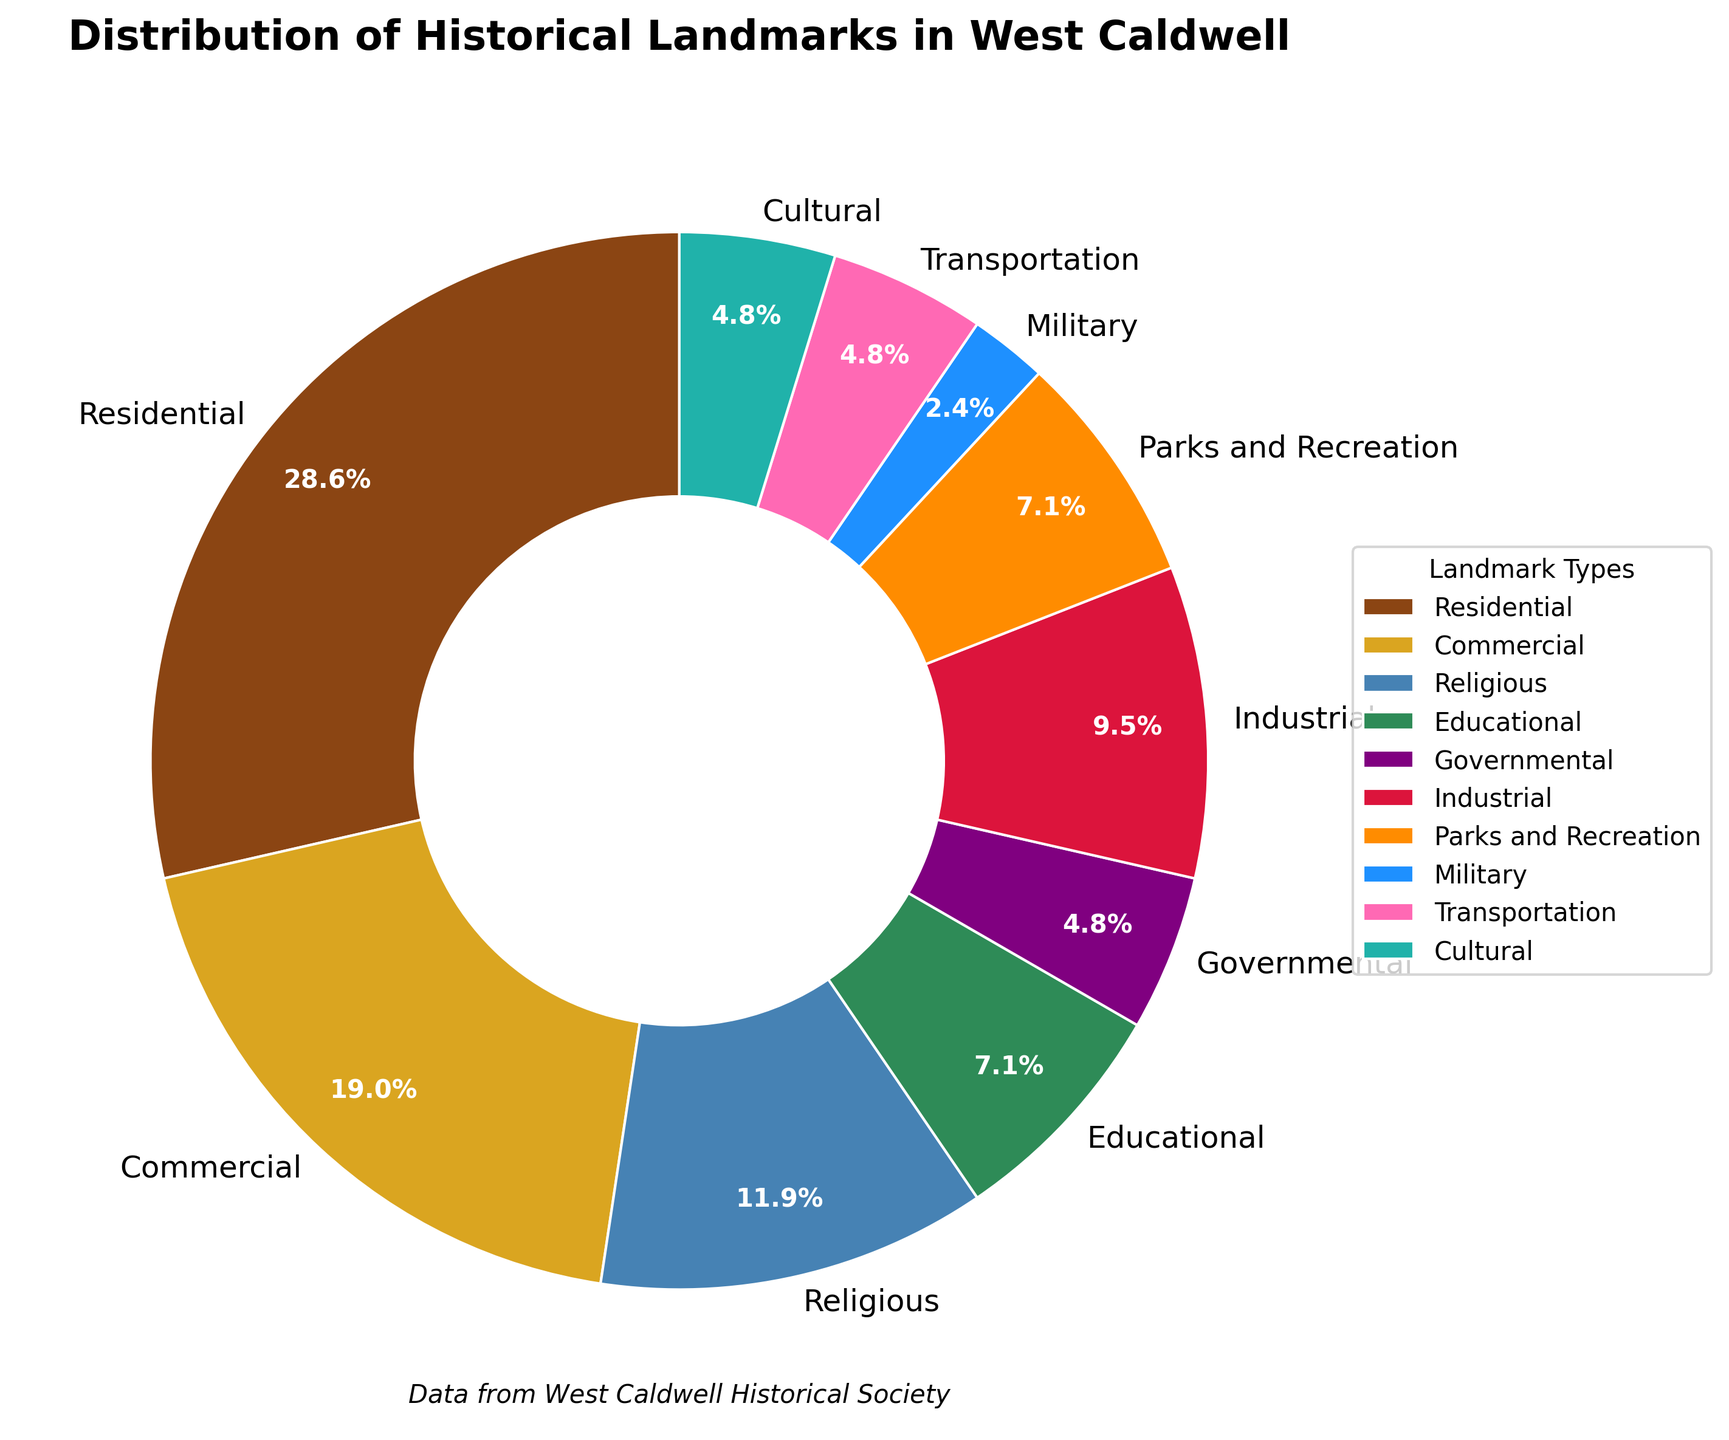Which type of historical landmark has the highest count? To find the type with the highest count, look for the wedge with the largest size in the pie chart. Residential has the largest wedge.
Answer: Residential Which type of historical landmark has the lowest count? Identify the smallest wedge in the pie chart. The Military type has the smallest wedge.
Answer: Military What is the total percentage of residential and commercial landmarks? The Residential wedge covers 30.8% and the Commercial wedge covers 20.5%. Adding these percentages: 30.8% + 20.5% = 51.3%.
Answer: 51.3% Which landmark types form a total of more than 50%? To find landmark types forming more than 50%, sum up the largest wedges until surpassing 50%. Residential (30.8%) + Commercial (20.5%) = 51.3%.
Answer: Residential and Commercial How do the counts of educational and industrial landmarks compare? Look at the size of the wedges for Educational and Industrial. Educational has 3 landmarks and Industrial has 4 landmarks.
Answer: Industrial has 1 more than Educational What is the combined count of religious, educational, and governmental landmarks? Sum the counts of the respective wedges: Religious (5) + Educational (3) + Governmental (2) = 10.
Answer: 10 Which type of landmark is represented by the green wedge? Identify the color of the wedge representing the type. The green wedge corresponds to Educational landmarks.
Answer: Educational How does the number of industrial landmarks compare to parks and recreation landmarks? Compare the wedges or numbers directly: Industrial has 4 landmarks, Parks and Recreation have 3.
Answer: Industrial has 1 more What fraction of landmarks are governmental landmarks? Governmental landmarks are 2 out of a total of 42 landmarks. As a fraction: 2/42 simplifies to 1/21.
Answer: 1/21 What is the average count of commercial, transportation, and cultural landmarks? Calculate the average of the counts: (8 for Commercial + 2 for Transportation + 2 for Cultural) / 3 = 12 / 3 = 4.
Answer: 4 